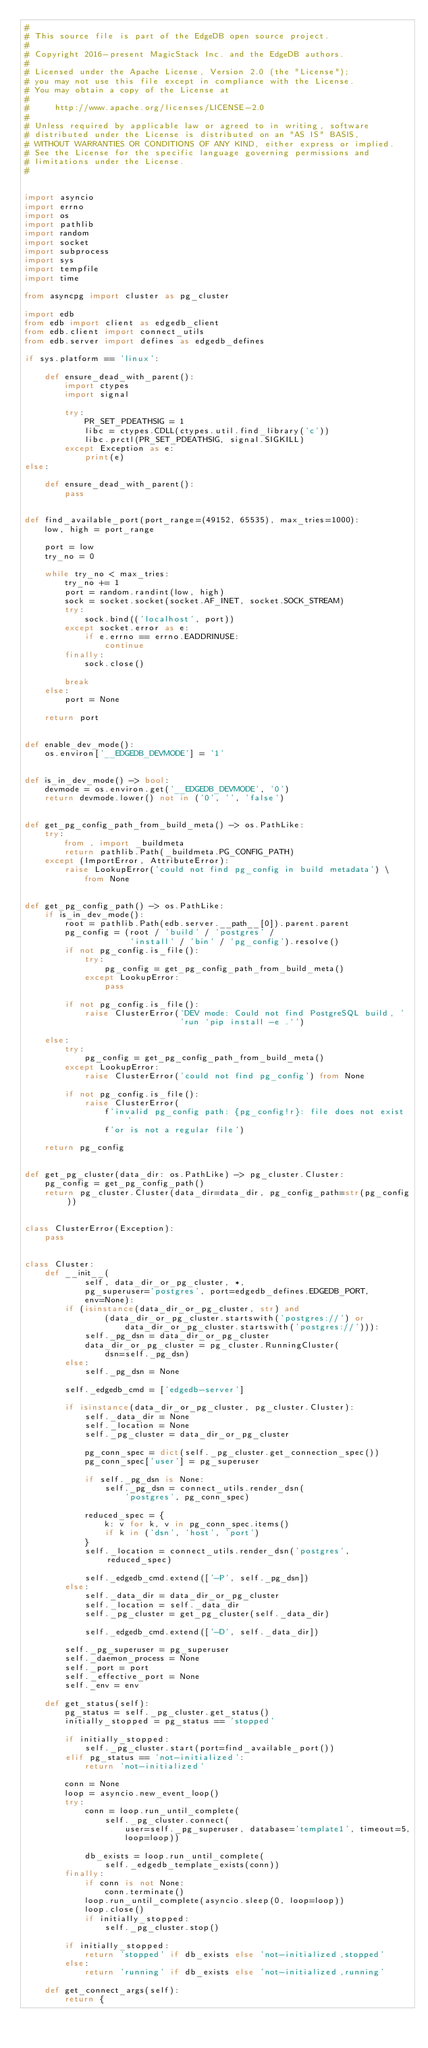Convert code to text. <code><loc_0><loc_0><loc_500><loc_500><_Python_>#
# This source file is part of the EdgeDB open source project.
#
# Copyright 2016-present MagicStack Inc. and the EdgeDB authors.
#
# Licensed under the Apache License, Version 2.0 (the "License");
# you may not use this file except in compliance with the License.
# You may obtain a copy of the License at
#
#     http://www.apache.org/licenses/LICENSE-2.0
#
# Unless required by applicable law or agreed to in writing, software
# distributed under the License is distributed on an "AS IS" BASIS,
# WITHOUT WARRANTIES OR CONDITIONS OF ANY KIND, either express or implied.
# See the License for the specific language governing permissions and
# limitations under the License.
#


import asyncio
import errno
import os
import pathlib
import random
import socket
import subprocess
import sys
import tempfile
import time

from asyncpg import cluster as pg_cluster

import edb
from edb import client as edgedb_client
from edb.client import connect_utils
from edb.server import defines as edgedb_defines

if sys.platform == 'linux':

    def ensure_dead_with_parent():
        import ctypes
        import signal

        try:
            PR_SET_PDEATHSIG = 1
            libc = ctypes.CDLL(ctypes.util.find_library('c'))
            libc.prctl(PR_SET_PDEATHSIG, signal.SIGKILL)
        except Exception as e:
            print(e)
else:

    def ensure_dead_with_parent():
        pass


def find_available_port(port_range=(49152, 65535), max_tries=1000):
    low, high = port_range

    port = low
    try_no = 0

    while try_no < max_tries:
        try_no += 1
        port = random.randint(low, high)
        sock = socket.socket(socket.AF_INET, socket.SOCK_STREAM)
        try:
            sock.bind(('localhost', port))
        except socket.error as e:
            if e.errno == errno.EADDRINUSE:
                continue
        finally:
            sock.close()

        break
    else:
        port = None

    return port


def enable_dev_mode():
    os.environ['__EDGEDB_DEVMODE'] = '1'


def is_in_dev_mode() -> bool:
    devmode = os.environ.get('__EDGEDB_DEVMODE', '0')
    return devmode.lower() not in ('0', '', 'false')


def get_pg_config_path_from_build_meta() -> os.PathLike:
    try:
        from . import _buildmeta
        return pathlib.Path(_buildmeta.PG_CONFIG_PATH)
    except (ImportError, AttributeError):
        raise LookupError('could not find pg_config in build metadata') \
            from None


def get_pg_config_path() -> os.PathLike:
    if is_in_dev_mode():
        root = pathlib.Path(edb.server.__path__[0]).parent.parent
        pg_config = (root / 'build' / 'postgres' /
                     'install' / 'bin' / 'pg_config').resolve()
        if not pg_config.is_file():
            try:
                pg_config = get_pg_config_path_from_build_meta()
            except LookupError:
                pass

        if not pg_config.is_file():
            raise ClusterError('DEV mode: Could not find PostgreSQL build, '
                               'run `pip install -e .`')

    else:
        try:
            pg_config = get_pg_config_path_from_build_meta()
        except LookupError:
            raise ClusterError('could not find pg_config') from None

        if not pg_config.is_file():
            raise ClusterError(
                f'invalid pg_config path: {pg_config!r}: file does not exist '
                f'or is not a regular file')

    return pg_config


def get_pg_cluster(data_dir: os.PathLike) -> pg_cluster.Cluster:
    pg_config = get_pg_config_path()
    return pg_cluster.Cluster(data_dir=data_dir, pg_config_path=str(pg_config))


class ClusterError(Exception):
    pass


class Cluster:
    def __init__(
            self, data_dir_or_pg_cluster, *,
            pg_superuser='postgres', port=edgedb_defines.EDGEDB_PORT,
            env=None):
        if (isinstance(data_dir_or_pg_cluster, str) and
                (data_dir_or_pg_cluster.startswith('postgres://') or
                    data_dir_or_pg_cluster.startswith('postgres://'))):
            self._pg_dsn = data_dir_or_pg_cluster
            data_dir_or_pg_cluster = pg_cluster.RunningCluster(
                dsn=self._pg_dsn)
        else:
            self._pg_dsn = None

        self._edgedb_cmd = ['edgedb-server']

        if isinstance(data_dir_or_pg_cluster, pg_cluster.Cluster):
            self._data_dir = None
            self._location = None
            self._pg_cluster = data_dir_or_pg_cluster

            pg_conn_spec = dict(self._pg_cluster.get_connection_spec())
            pg_conn_spec['user'] = pg_superuser

            if self._pg_dsn is None:
                self._pg_dsn = connect_utils.render_dsn(
                    'postgres', pg_conn_spec)

            reduced_spec = {
                k: v for k, v in pg_conn_spec.items()
                if k in ('dsn', 'host', 'port')
            }
            self._location = connect_utils.render_dsn('postgres', reduced_spec)

            self._edgedb_cmd.extend(['-P', self._pg_dsn])
        else:
            self._data_dir = data_dir_or_pg_cluster
            self._location = self._data_dir
            self._pg_cluster = get_pg_cluster(self._data_dir)

            self._edgedb_cmd.extend(['-D', self._data_dir])

        self._pg_superuser = pg_superuser
        self._daemon_process = None
        self._port = port
        self._effective_port = None
        self._env = env

    def get_status(self):
        pg_status = self._pg_cluster.get_status()
        initially_stopped = pg_status == 'stopped'

        if initially_stopped:
            self._pg_cluster.start(port=find_available_port())
        elif pg_status == 'not-initialized':
            return 'not-initialized'

        conn = None
        loop = asyncio.new_event_loop()
        try:
            conn = loop.run_until_complete(
                self._pg_cluster.connect(
                    user=self._pg_superuser, database='template1', timeout=5,
                    loop=loop))

            db_exists = loop.run_until_complete(
                self._edgedb_template_exists(conn))
        finally:
            if conn is not None:
                conn.terminate()
            loop.run_until_complete(asyncio.sleep(0, loop=loop))
            loop.close()
            if initially_stopped:
                self._pg_cluster.stop()

        if initially_stopped:
            return 'stopped' if db_exists else 'not-initialized,stopped'
        else:
            return 'running' if db_exists else 'not-initialized,running'

    def get_connect_args(self):
        return {</code> 